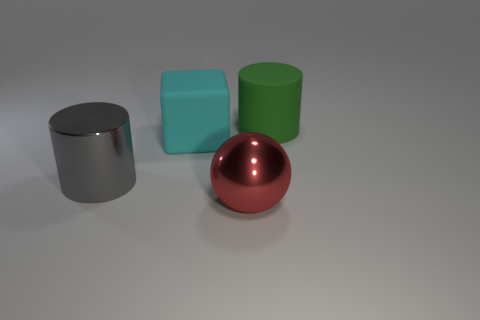Add 2 red metal balls. How many objects exist? 6 Subtract all cubes. How many objects are left? 3 Add 1 large green cylinders. How many large green cylinders are left? 2 Add 4 gray matte cylinders. How many gray matte cylinders exist? 4 Subtract 1 gray cylinders. How many objects are left? 3 Subtract all metal cylinders. Subtract all large blocks. How many objects are left? 2 